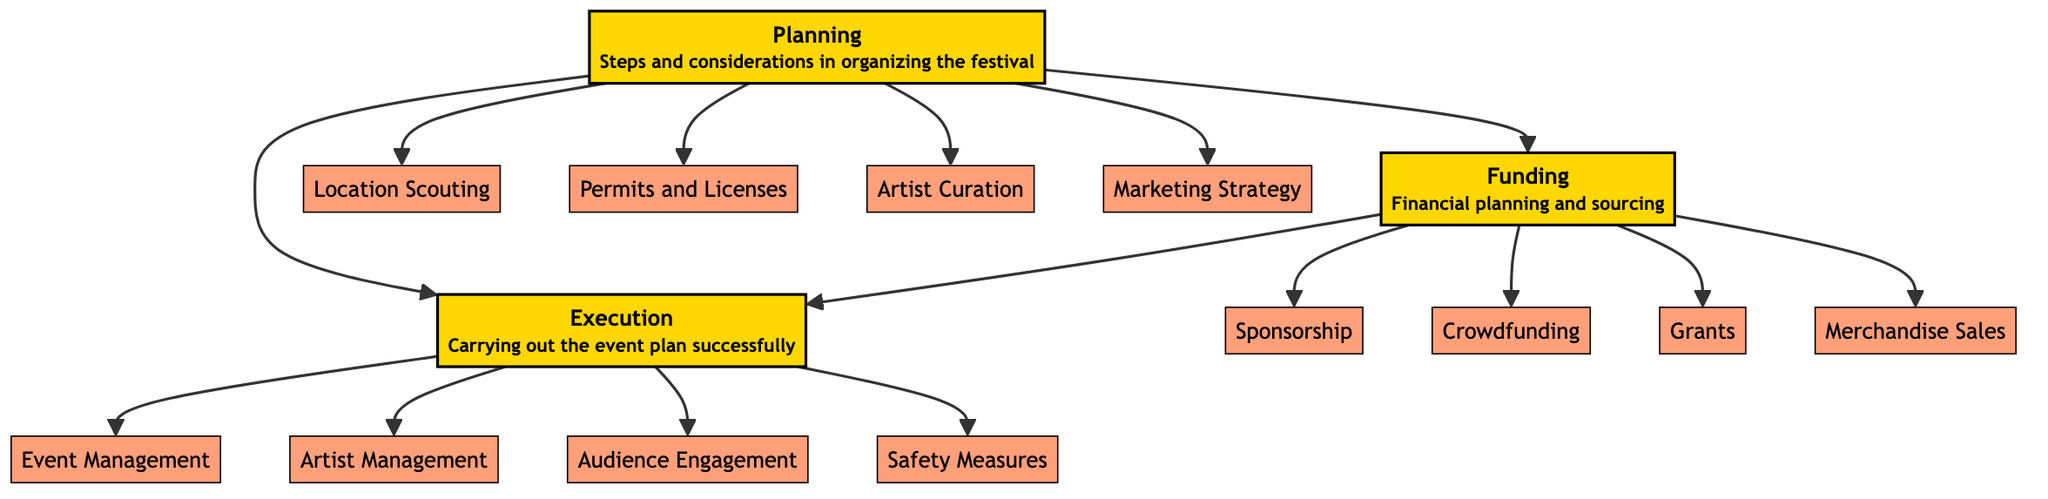What are the three main components of the festival's anatomy? The diagram clearly indicates three main components labeled as Planning, Funding, and Execution. Each of these components has a small description that elaborates on their roles in the festival.
Answer: Planning, Funding, Execution How many sub-components are listed under Planning? By examining the Planning component, we can see that there are four sub-nodes connected to it: Location Scouting, Permits and Licenses, Artist Curation, and Marketing Strategy. Counting these gives us a total of four sub-components.
Answer: 4 Which node directly follows Funding? The diagram shows that Execution directly follows Funding in the flow, indicating that after securing funding, the next step is executing the festival plans.
Answer: Execution What funding sources are mentioned in the diagram? The diagram indicates four funding sources connected to the Funding node: Sponsorship, Crowdfunding, Grants, and Merchandise Sales. These sources detail the potential ways to acquire financial support for the festival.
Answer: Sponsorship, Crowdfunding, Grants, Merchandise Sales What do Planning and Execution have in common? Both Planning and Execution nodes are connected directly in the diagram, indicating a direct relationship where planning informs the execution process. They are also both main nodes that lead to sub-components, showing their interconnected importance in festival organization.
Answer: Direct relationship What is the last step in the execution phase? Looking at the Execution phase, the last sub-component listed is Safety Measures. This indicates that ensuring safety is a final consideration during the execution of the event.
Answer: Safety Measures How many total nodes are there in the diagram? By counting all the nodes, both main and sub-nodes, we can see there are a total of 14 nodes in the diagram (3 main nodes and 11 sub-nodes).
Answer: 14 Which sub-node is related to managing artists? The sub-node that pertains to managing artists is Artist Management. This aspect emphasizes the importance of overseeing artists during the execution phase of the festival.
Answer: Artist Management How many nodes are there under Funding? Under the Funding component, there are four sub-nodes outlined: Sponsorship, Crowdfunding, Grants, and Merchandise Sales, which make a total of four nodes under this component.
Answer: 4 